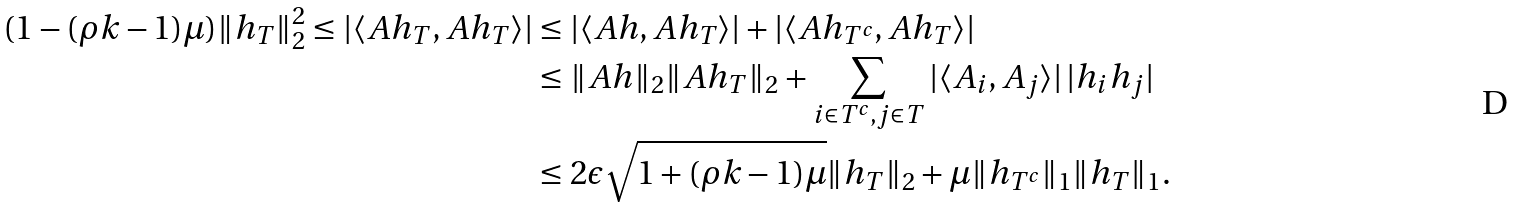<formula> <loc_0><loc_0><loc_500><loc_500>( 1 - ( \rho k - 1 ) \mu ) \| h _ { T } \| _ { 2 } ^ { 2 } \leq | \langle A h _ { T } , A h _ { T } \rangle | & \leq | \langle A h , A h _ { T } \rangle | + | \langle A h _ { T ^ { c } } , A h _ { T } \rangle | \\ & \leq \| A h \| _ { 2 } \| A h _ { T } \| _ { 2 } + \sum _ { i \in T ^ { c } , j \in T } | \langle A _ { i } , A _ { j } \rangle | \, | h _ { i } h _ { j } | \\ & \leq 2 \epsilon \sqrt { 1 + ( \rho k - 1 ) \mu } \| h _ { T } \| _ { 2 } + \mu \| h _ { T ^ { c } } \| _ { 1 } \| h _ { T } \| _ { 1 } .</formula> 